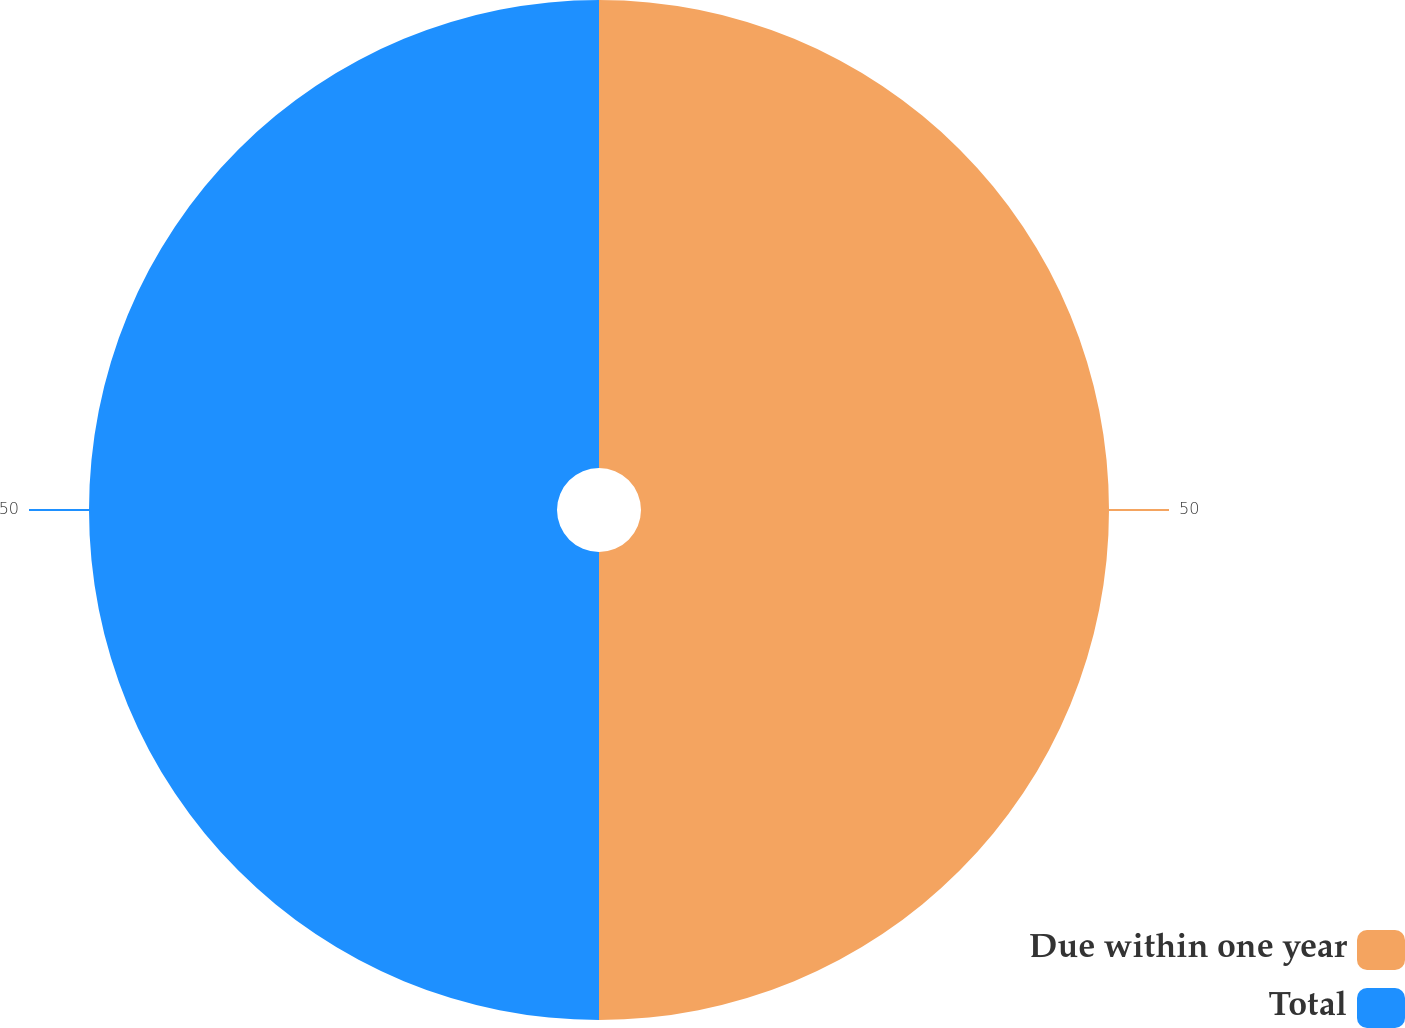<chart> <loc_0><loc_0><loc_500><loc_500><pie_chart><fcel>Due within one year<fcel>Total<nl><fcel>50.0%<fcel>50.0%<nl></chart> 